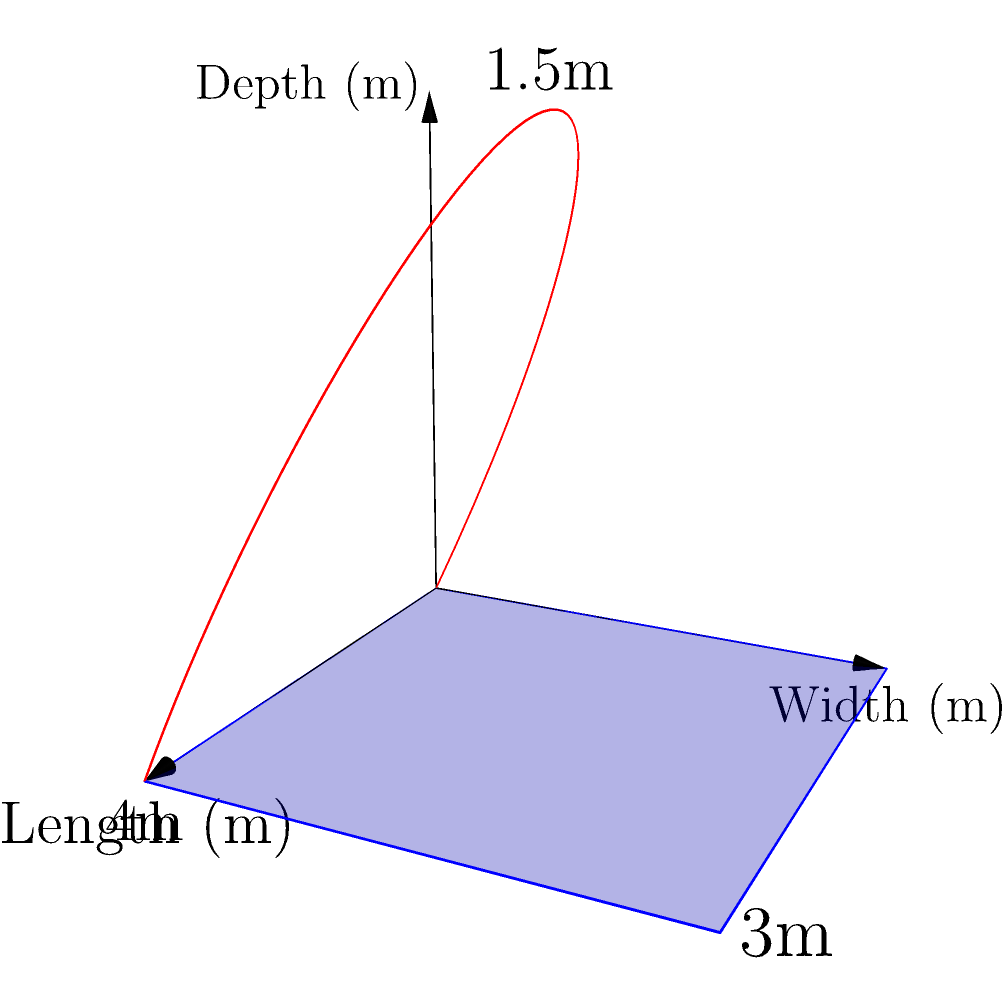As a couples therapist helping newlyweds design their dream home, you're assisting a couple in planning their backyard swimming pool. The pool has a rectangular base of 4m by 3m, but its depth varies along its length. The depth curve can be approximated by the function $d(x) = -\frac{3}{8}x^2 + \frac{3}{2}x$, where $x$ is the distance along the length of the pool (in meters) and $d(x)$ is the depth at that point (in meters). Calculate the volume of water needed to fill this irregularly shaped pool. To find the volume of the irregularly shaped pool, we need to use integration. Here's the step-by-step process:

1) The volume of the pool can be calculated by integrating the cross-sectional area along the length of the pool. 

2) The cross-sectional area at any point $x$ is the width of the pool multiplied by the depth at that point:
   $A(x) = 3 \cdot d(x) = 3 \cdot (-\frac{3}{8}x^2 + \frac{3}{2}x)$

3) The volume is the integral of this area function over the length of the pool:
   $$V = \int_0^4 A(x) dx = \int_0^4 3 \cdot (-\frac{3}{8}x^2 + \frac{3}{2}x) dx$$

4) Simplifying the integrand:
   $$V = \int_0^4 (-\frac{9}{8}x^2 + \frac{9}{2}x) dx$$

5) Integrating:
   $$V = [-\frac{3}{8}x^3 + \frac{9}{4}x^2]_0^4$$

6) Evaluating the integral:
   $$V = [-\frac{3}{8}(64) + \frac{9}{4}(16)] - [-\frac{3}{8}(0) + \frac{9}{4}(0)]$$
   $$V = [-24 + 36] - [0]$$
   $$V = 12$$

Therefore, the volume of the pool is 12 cubic meters.
Answer: 12 m³ 